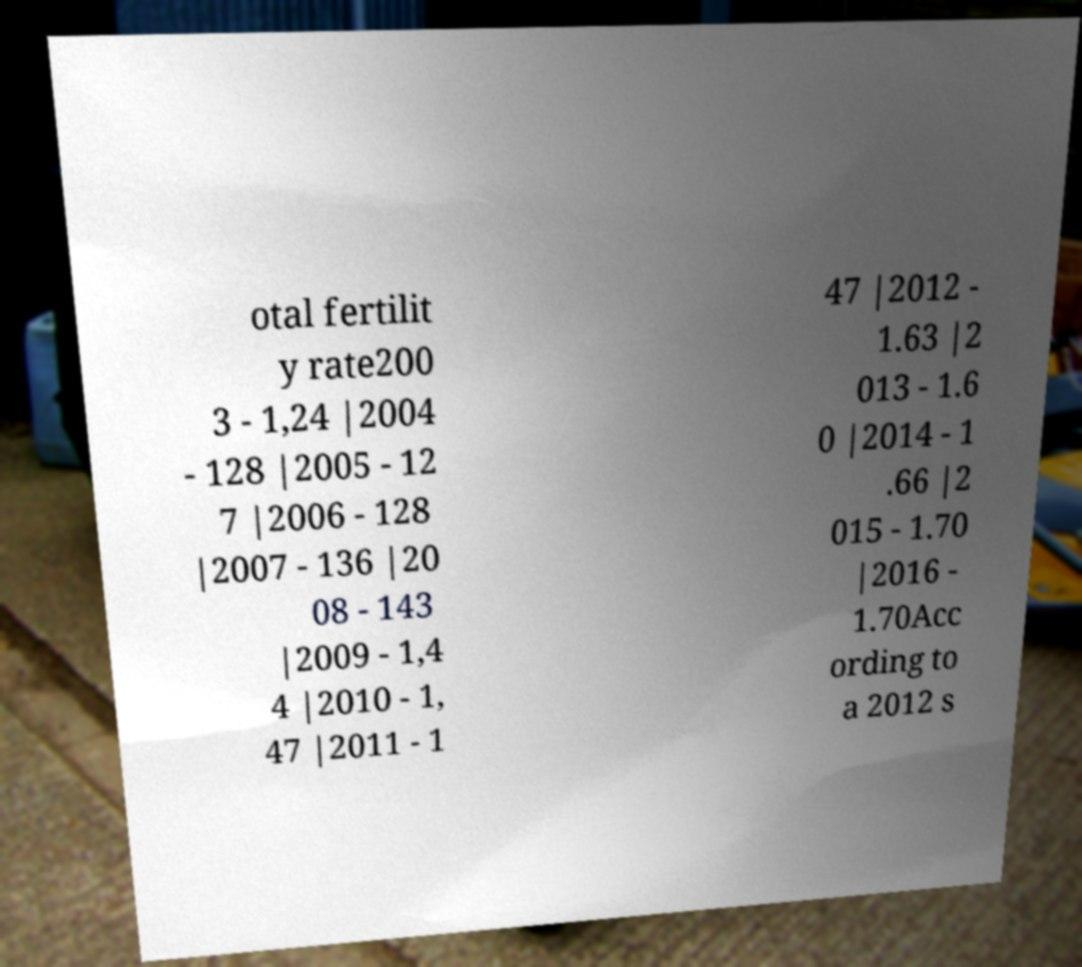Could you extract and type out the text from this image? otal fertilit y rate200 3 - 1,24 |2004 - 128 |2005 - 12 7 |2006 - 128 |2007 - 136 |20 08 - 143 |2009 - 1,4 4 |2010 - 1, 47 |2011 - 1 47 |2012 - 1.63 |2 013 - 1.6 0 |2014 - 1 .66 |2 015 - 1.70 |2016 - 1.70Acc ording to a 2012 s 